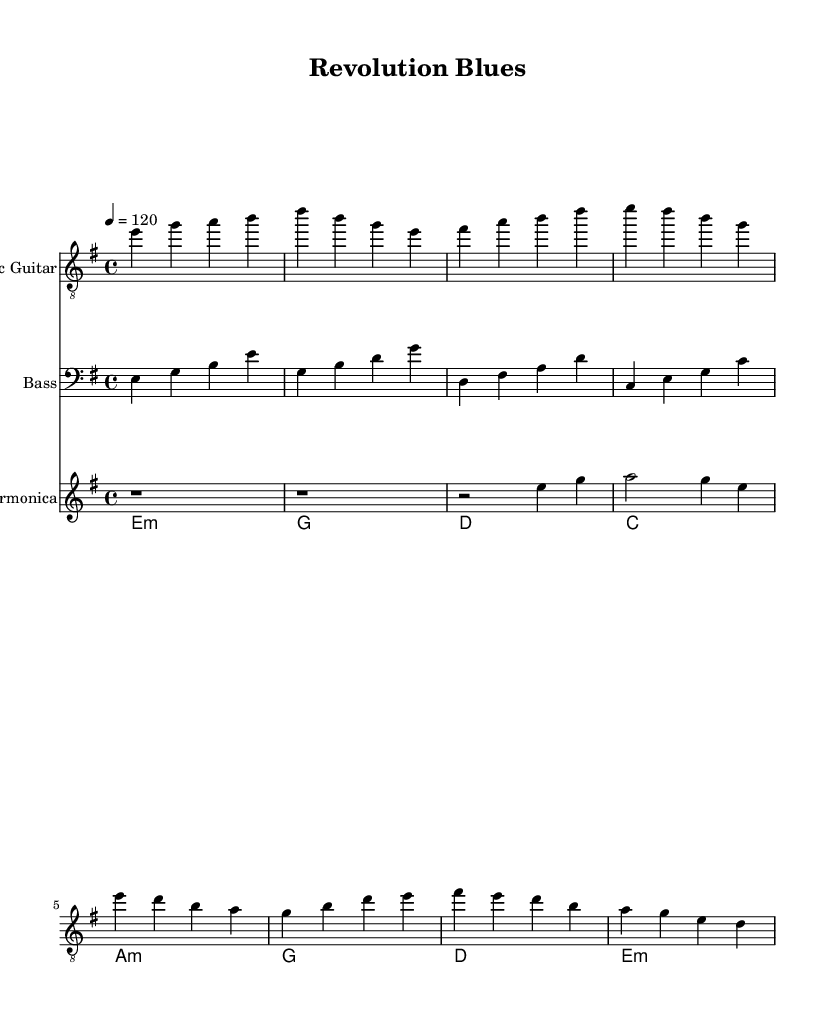What is the key signature of this music? The key signature indicates the piece is in E minor, which has one sharp (F#). This is determined by looking at the key signature at the beginning of the staff.
Answer: E minor What is the time signature of this piece? The time signature displayed at the beginning of the sheet music indicates the piece is in 4/4 time, meaning there are four beats per measure and the quarter note gets one beat.
Answer: 4/4 What is the tempo marking for this piece? The tempo marking states "4 = 120," which means there should be 120 beats per minute. This can be found in the tempo line at the start of the music.
Answer: 120 How many measures are in the verse section? The verse section consists of four measures, which can be counted by looking at the groupings of notes and the vertical lines indicating the end of each measure.
Answer: 4 What type of guitar is featured prominently in the music? The sheet music clearly labels one of the staves as "Electric Guitar," indicating that this type of guitar is the primary focus within the arrangement.
Answer: Electric Guitar Which instrument has a treble clef and plays eighth notes? The Electric Guitar part is written in treble clef and contains eighth notes, evident from the notes in the staff and their rhythmic representation.
Answer: Electric Guitar What chord begins the progression? The chord that starts the progression is E minor, identifiable from the chord names written above the staff and its position in the first measure.
Answer: E minor 